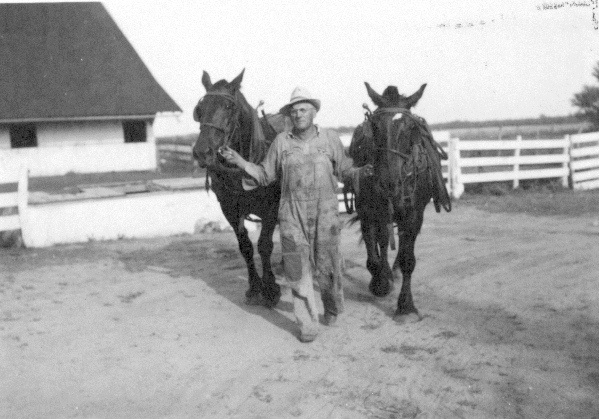Describe the objects in this image and their specific colors. I can see horse in white, black, gray, darkgray, and lightgray tones, people in white, darkgray, gray, black, and lightgray tones, and horse in white, black, gray, darkgray, and lightgray tones in this image. 